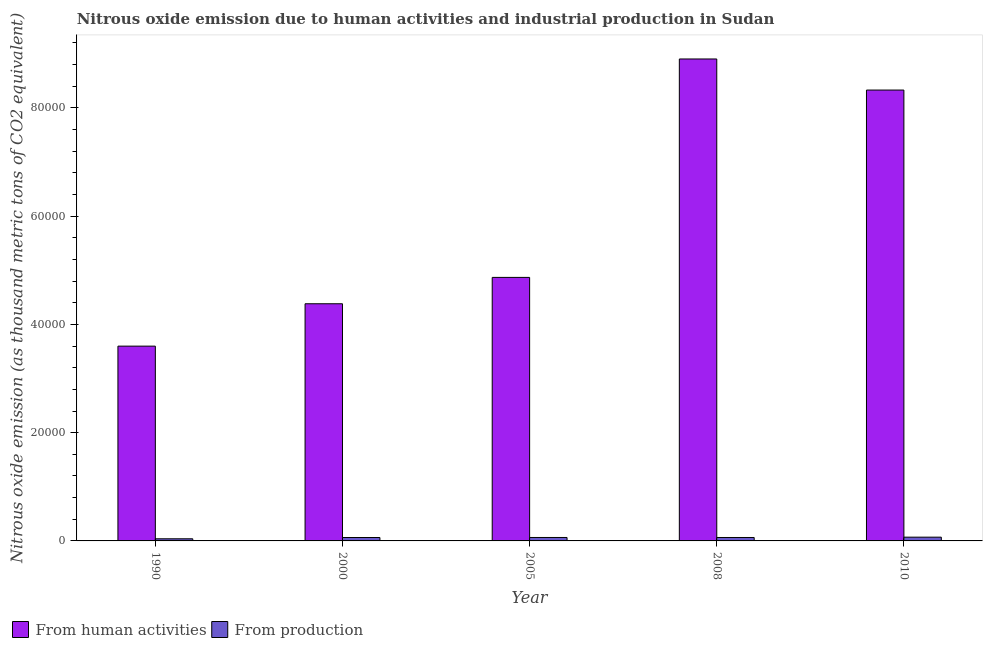How many different coloured bars are there?
Your answer should be very brief. 2. How many groups of bars are there?
Give a very brief answer. 5. Are the number of bars on each tick of the X-axis equal?
Give a very brief answer. Yes. How many bars are there on the 1st tick from the left?
Keep it short and to the point. 2. What is the amount of emissions from human activities in 2008?
Offer a very short reply. 8.90e+04. Across all years, what is the maximum amount of emissions generated from industries?
Ensure brevity in your answer.  694.6. Across all years, what is the minimum amount of emissions generated from industries?
Your response must be concise. 395. In which year was the amount of emissions from human activities maximum?
Your answer should be compact. 2008. What is the total amount of emissions generated from industries in the graph?
Provide a short and direct response. 2989.9. What is the difference between the amount of emissions from human activities in 1990 and that in 2000?
Your answer should be very brief. -7827.3. What is the difference between the amount of emissions from human activities in 2008 and the amount of emissions generated from industries in 2010?
Make the answer very short. 5743.3. What is the average amount of emissions generated from industries per year?
Make the answer very short. 597.98. In the year 2008, what is the difference between the amount of emissions generated from industries and amount of emissions from human activities?
Offer a very short reply. 0. In how many years, is the amount of emissions generated from industries greater than 40000 thousand metric tons?
Make the answer very short. 0. What is the ratio of the amount of emissions generated from industries in 2000 to that in 2008?
Provide a succinct answer. 1. What is the difference between the highest and the second highest amount of emissions from human activities?
Offer a very short reply. 5743.3. What is the difference between the highest and the lowest amount of emissions generated from industries?
Your answer should be very brief. 299.6. In how many years, is the amount of emissions generated from industries greater than the average amount of emissions generated from industries taken over all years?
Give a very brief answer. 4. What does the 1st bar from the left in 2005 represents?
Ensure brevity in your answer.  From human activities. What does the 1st bar from the right in 2005 represents?
Keep it short and to the point. From production. How many bars are there?
Provide a short and direct response. 10. Are all the bars in the graph horizontal?
Your answer should be very brief. No. What is the difference between two consecutive major ticks on the Y-axis?
Make the answer very short. 2.00e+04. Are the values on the major ticks of Y-axis written in scientific E-notation?
Offer a very short reply. No. Does the graph contain any zero values?
Your response must be concise. No. Does the graph contain grids?
Offer a very short reply. No. What is the title of the graph?
Your response must be concise. Nitrous oxide emission due to human activities and industrial production in Sudan. Does "Girls" appear as one of the legend labels in the graph?
Make the answer very short. No. What is the label or title of the Y-axis?
Ensure brevity in your answer.  Nitrous oxide emission (as thousand metric tons of CO2 equivalent). What is the Nitrous oxide emission (as thousand metric tons of CO2 equivalent) in From human activities in 1990?
Make the answer very short. 3.60e+04. What is the Nitrous oxide emission (as thousand metric tons of CO2 equivalent) in From production in 1990?
Provide a succinct answer. 395. What is the Nitrous oxide emission (as thousand metric tons of CO2 equivalent) of From human activities in 2000?
Provide a succinct answer. 4.38e+04. What is the Nitrous oxide emission (as thousand metric tons of CO2 equivalent) of From production in 2000?
Offer a very short reply. 630.1. What is the Nitrous oxide emission (as thousand metric tons of CO2 equivalent) of From human activities in 2005?
Your answer should be very brief. 4.87e+04. What is the Nitrous oxide emission (as thousand metric tons of CO2 equivalent) in From production in 2005?
Ensure brevity in your answer.  637.4. What is the Nitrous oxide emission (as thousand metric tons of CO2 equivalent) in From human activities in 2008?
Your answer should be compact. 8.90e+04. What is the Nitrous oxide emission (as thousand metric tons of CO2 equivalent) in From production in 2008?
Keep it short and to the point. 632.8. What is the Nitrous oxide emission (as thousand metric tons of CO2 equivalent) of From human activities in 2010?
Offer a very short reply. 8.33e+04. What is the Nitrous oxide emission (as thousand metric tons of CO2 equivalent) of From production in 2010?
Offer a very short reply. 694.6. Across all years, what is the maximum Nitrous oxide emission (as thousand metric tons of CO2 equivalent) of From human activities?
Your response must be concise. 8.90e+04. Across all years, what is the maximum Nitrous oxide emission (as thousand metric tons of CO2 equivalent) of From production?
Your response must be concise. 694.6. Across all years, what is the minimum Nitrous oxide emission (as thousand metric tons of CO2 equivalent) in From human activities?
Give a very brief answer. 3.60e+04. Across all years, what is the minimum Nitrous oxide emission (as thousand metric tons of CO2 equivalent) in From production?
Offer a very short reply. 395. What is the total Nitrous oxide emission (as thousand metric tons of CO2 equivalent) in From human activities in the graph?
Provide a succinct answer. 3.01e+05. What is the total Nitrous oxide emission (as thousand metric tons of CO2 equivalent) of From production in the graph?
Provide a succinct answer. 2989.9. What is the difference between the Nitrous oxide emission (as thousand metric tons of CO2 equivalent) in From human activities in 1990 and that in 2000?
Your answer should be very brief. -7827.3. What is the difference between the Nitrous oxide emission (as thousand metric tons of CO2 equivalent) in From production in 1990 and that in 2000?
Your answer should be compact. -235.1. What is the difference between the Nitrous oxide emission (as thousand metric tons of CO2 equivalent) in From human activities in 1990 and that in 2005?
Your answer should be very brief. -1.27e+04. What is the difference between the Nitrous oxide emission (as thousand metric tons of CO2 equivalent) of From production in 1990 and that in 2005?
Offer a very short reply. -242.4. What is the difference between the Nitrous oxide emission (as thousand metric tons of CO2 equivalent) of From human activities in 1990 and that in 2008?
Your answer should be compact. -5.31e+04. What is the difference between the Nitrous oxide emission (as thousand metric tons of CO2 equivalent) in From production in 1990 and that in 2008?
Offer a very short reply. -237.8. What is the difference between the Nitrous oxide emission (as thousand metric tons of CO2 equivalent) of From human activities in 1990 and that in 2010?
Your answer should be very brief. -4.73e+04. What is the difference between the Nitrous oxide emission (as thousand metric tons of CO2 equivalent) in From production in 1990 and that in 2010?
Offer a very short reply. -299.6. What is the difference between the Nitrous oxide emission (as thousand metric tons of CO2 equivalent) of From human activities in 2000 and that in 2005?
Your answer should be very brief. -4871.9. What is the difference between the Nitrous oxide emission (as thousand metric tons of CO2 equivalent) in From human activities in 2000 and that in 2008?
Offer a very short reply. -4.52e+04. What is the difference between the Nitrous oxide emission (as thousand metric tons of CO2 equivalent) in From production in 2000 and that in 2008?
Keep it short and to the point. -2.7. What is the difference between the Nitrous oxide emission (as thousand metric tons of CO2 equivalent) of From human activities in 2000 and that in 2010?
Give a very brief answer. -3.95e+04. What is the difference between the Nitrous oxide emission (as thousand metric tons of CO2 equivalent) in From production in 2000 and that in 2010?
Provide a short and direct response. -64.5. What is the difference between the Nitrous oxide emission (as thousand metric tons of CO2 equivalent) of From human activities in 2005 and that in 2008?
Provide a succinct answer. -4.04e+04. What is the difference between the Nitrous oxide emission (as thousand metric tons of CO2 equivalent) of From human activities in 2005 and that in 2010?
Make the answer very short. -3.46e+04. What is the difference between the Nitrous oxide emission (as thousand metric tons of CO2 equivalent) in From production in 2005 and that in 2010?
Your answer should be compact. -57.2. What is the difference between the Nitrous oxide emission (as thousand metric tons of CO2 equivalent) in From human activities in 2008 and that in 2010?
Offer a terse response. 5743.3. What is the difference between the Nitrous oxide emission (as thousand metric tons of CO2 equivalent) of From production in 2008 and that in 2010?
Provide a succinct answer. -61.8. What is the difference between the Nitrous oxide emission (as thousand metric tons of CO2 equivalent) in From human activities in 1990 and the Nitrous oxide emission (as thousand metric tons of CO2 equivalent) in From production in 2000?
Offer a terse response. 3.54e+04. What is the difference between the Nitrous oxide emission (as thousand metric tons of CO2 equivalent) of From human activities in 1990 and the Nitrous oxide emission (as thousand metric tons of CO2 equivalent) of From production in 2005?
Your answer should be very brief. 3.53e+04. What is the difference between the Nitrous oxide emission (as thousand metric tons of CO2 equivalent) in From human activities in 1990 and the Nitrous oxide emission (as thousand metric tons of CO2 equivalent) in From production in 2008?
Your answer should be compact. 3.54e+04. What is the difference between the Nitrous oxide emission (as thousand metric tons of CO2 equivalent) in From human activities in 1990 and the Nitrous oxide emission (as thousand metric tons of CO2 equivalent) in From production in 2010?
Provide a short and direct response. 3.53e+04. What is the difference between the Nitrous oxide emission (as thousand metric tons of CO2 equivalent) in From human activities in 2000 and the Nitrous oxide emission (as thousand metric tons of CO2 equivalent) in From production in 2005?
Offer a very short reply. 4.32e+04. What is the difference between the Nitrous oxide emission (as thousand metric tons of CO2 equivalent) in From human activities in 2000 and the Nitrous oxide emission (as thousand metric tons of CO2 equivalent) in From production in 2008?
Keep it short and to the point. 4.32e+04. What is the difference between the Nitrous oxide emission (as thousand metric tons of CO2 equivalent) of From human activities in 2000 and the Nitrous oxide emission (as thousand metric tons of CO2 equivalent) of From production in 2010?
Give a very brief answer. 4.31e+04. What is the difference between the Nitrous oxide emission (as thousand metric tons of CO2 equivalent) of From human activities in 2005 and the Nitrous oxide emission (as thousand metric tons of CO2 equivalent) of From production in 2008?
Ensure brevity in your answer.  4.81e+04. What is the difference between the Nitrous oxide emission (as thousand metric tons of CO2 equivalent) of From human activities in 2005 and the Nitrous oxide emission (as thousand metric tons of CO2 equivalent) of From production in 2010?
Give a very brief answer. 4.80e+04. What is the difference between the Nitrous oxide emission (as thousand metric tons of CO2 equivalent) of From human activities in 2008 and the Nitrous oxide emission (as thousand metric tons of CO2 equivalent) of From production in 2010?
Offer a very short reply. 8.83e+04. What is the average Nitrous oxide emission (as thousand metric tons of CO2 equivalent) in From human activities per year?
Keep it short and to the point. 6.02e+04. What is the average Nitrous oxide emission (as thousand metric tons of CO2 equivalent) in From production per year?
Your answer should be very brief. 597.98. In the year 1990, what is the difference between the Nitrous oxide emission (as thousand metric tons of CO2 equivalent) of From human activities and Nitrous oxide emission (as thousand metric tons of CO2 equivalent) of From production?
Make the answer very short. 3.56e+04. In the year 2000, what is the difference between the Nitrous oxide emission (as thousand metric tons of CO2 equivalent) of From human activities and Nitrous oxide emission (as thousand metric tons of CO2 equivalent) of From production?
Provide a succinct answer. 4.32e+04. In the year 2005, what is the difference between the Nitrous oxide emission (as thousand metric tons of CO2 equivalent) of From human activities and Nitrous oxide emission (as thousand metric tons of CO2 equivalent) of From production?
Your answer should be compact. 4.80e+04. In the year 2008, what is the difference between the Nitrous oxide emission (as thousand metric tons of CO2 equivalent) of From human activities and Nitrous oxide emission (as thousand metric tons of CO2 equivalent) of From production?
Make the answer very short. 8.84e+04. In the year 2010, what is the difference between the Nitrous oxide emission (as thousand metric tons of CO2 equivalent) of From human activities and Nitrous oxide emission (as thousand metric tons of CO2 equivalent) of From production?
Offer a very short reply. 8.26e+04. What is the ratio of the Nitrous oxide emission (as thousand metric tons of CO2 equivalent) in From human activities in 1990 to that in 2000?
Offer a terse response. 0.82. What is the ratio of the Nitrous oxide emission (as thousand metric tons of CO2 equivalent) of From production in 1990 to that in 2000?
Offer a terse response. 0.63. What is the ratio of the Nitrous oxide emission (as thousand metric tons of CO2 equivalent) in From human activities in 1990 to that in 2005?
Your response must be concise. 0.74. What is the ratio of the Nitrous oxide emission (as thousand metric tons of CO2 equivalent) in From production in 1990 to that in 2005?
Offer a terse response. 0.62. What is the ratio of the Nitrous oxide emission (as thousand metric tons of CO2 equivalent) in From human activities in 1990 to that in 2008?
Your answer should be very brief. 0.4. What is the ratio of the Nitrous oxide emission (as thousand metric tons of CO2 equivalent) of From production in 1990 to that in 2008?
Offer a very short reply. 0.62. What is the ratio of the Nitrous oxide emission (as thousand metric tons of CO2 equivalent) of From human activities in 1990 to that in 2010?
Your answer should be compact. 0.43. What is the ratio of the Nitrous oxide emission (as thousand metric tons of CO2 equivalent) in From production in 1990 to that in 2010?
Your response must be concise. 0.57. What is the ratio of the Nitrous oxide emission (as thousand metric tons of CO2 equivalent) of From human activities in 2000 to that in 2005?
Make the answer very short. 0.9. What is the ratio of the Nitrous oxide emission (as thousand metric tons of CO2 equivalent) in From production in 2000 to that in 2005?
Your answer should be compact. 0.99. What is the ratio of the Nitrous oxide emission (as thousand metric tons of CO2 equivalent) of From human activities in 2000 to that in 2008?
Offer a terse response. 0.49. What is the ratio of the Nitrous oxide emission (as thousand metric tons of CO2 equivalent) of From human activities in 2000 to that in 2010?
Provide a succinct answer. 0.53. What is the ratio of the Nitrous oxide emission (as thousand metric tons of CO2 equivalent) in From production in 2000 to that in 2010?
Provide a short and direct response. 0.91. What is the ratio of the Nitrous oxide emission (as thousand metric tons of CO2 equivalent) of From human activities in 2005 to that in 2008?
Your answer should be very brief. 0.55. What is the ratio of the Nitrous oxide emission (as thousand metric tons of CO2 equivalent) in From production in 2005 to that in 2008?
Ensure brevity in your answer.  1.01. What is the ratio of the Nitrous oxide emission (as thousand metric tons of CO2 equivalent) in From human activities in 2005 to that in 2010?
Offer a very short reply. 0.58. What is the ratio of the Nitrous oxide emission (as thousand metric tons of CO2 equivalent) of From production in 2005 to that in 2010?
Give a very brief answer. 0.92. What is the ratio of the Nitrous oxide emission (as thousand metric tons of CO2 equivalent) in From human activities in 2008 to that in 2010?
Give a very brief answer. 1.07. What is the ratio of the Nitrous oxide emission (as thousand metric tons of CO2 equivalent) in From production in 2008 to that in 2010?
Keep it short and to the point. 0.91. What is the difference between the highest and the second highest Nitrous oxide emission (as thousand metric tons of CO2 equivalent) of From human activities?
Make the answer very short. 5743.3. What is the difference between the highest and the second highest Nitrous oxide emission (as thousand metric tons of CO2 equivalent) of From production?
Offer a terse response. 57.2. What is the difference between the highest and the lowest Nitrous oxide emission (as thousand metric tons of CO2 equivalent) of From human activities?
Provide a short and direct response. 5.31e+04. What is the difference between the highest and the lowest Nitrous oxide emission (as thousand metric tons of CO2 equivalent) in From production?
Provide a succinct answer. 299.6. 